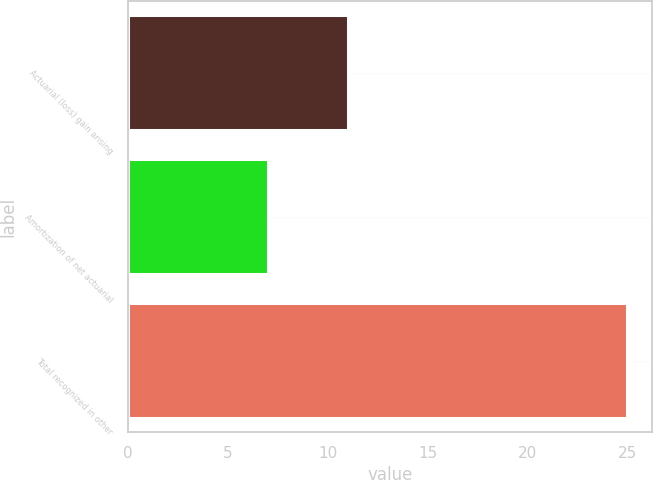Convert chart to OTSL. <chart><loc_0><loc_0><loc_500><loc_500><bar_chart><fcel>Actuarial (loss) gain arising<fcel>Amortization of net actuarial<fcel>Total recognized in other<nl><fcel>11<fcel>7<fcel>25<nl></chart> 